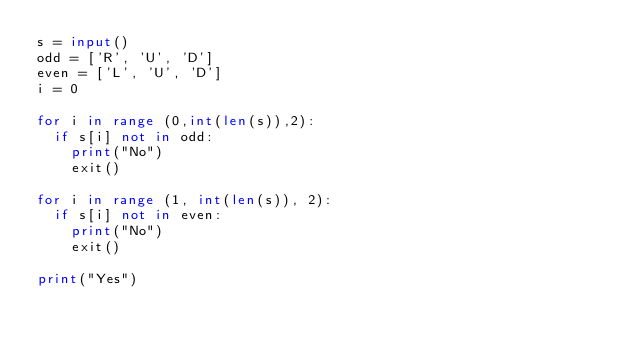Convert code to text. <code><loc_0><loc_0><loc_500><loc_500><_Python_>s = input()
odd = ['R', 'U', 'D']
even = ['L', 'U', 'D']
i = 0

for i in range (0,int(len(s)),2):
  if s[i] not in odd:
    print("No")
    exit()
    
for i in range (1, int(len(s)), 2):
  if s[i] not in even:
    print("No")
    exit()  

print("Yes")</code> 